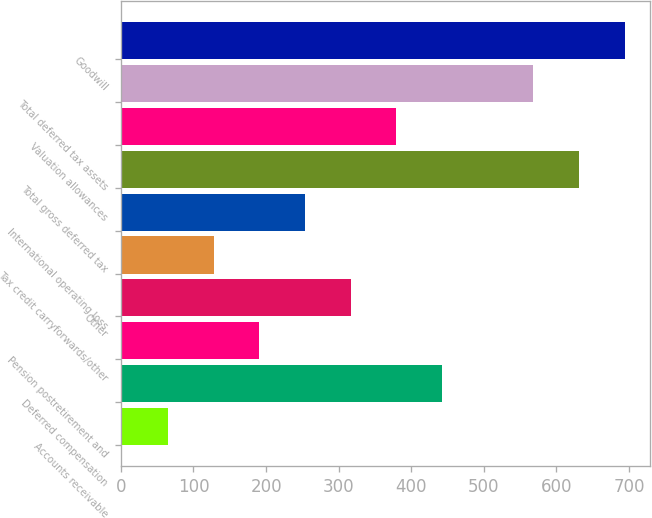Convert chart to OTSL. <chart><loc_0><loc_0><loc_500><loc_500><bar_chart><fcel>Accounts receivable<fcel>Deferred compensation<fcel>Pension postretirement and<fcel>Other<fcel>Tax credit carryforwards/other<fcel>International operating loss<fcel>Total gross deferred tax<fcel>Valuation allowances<fcel>Total deferred tax assets<fcel>Goodwill<nl><fcel>65.01<fcel>442.47<fcel>190.83<fcel>316.65<fcel>127.92<fcel>253.74<fcel>631.2<fcel>379.56<fcel>568.29<fcel>694.11<nl></chart> 